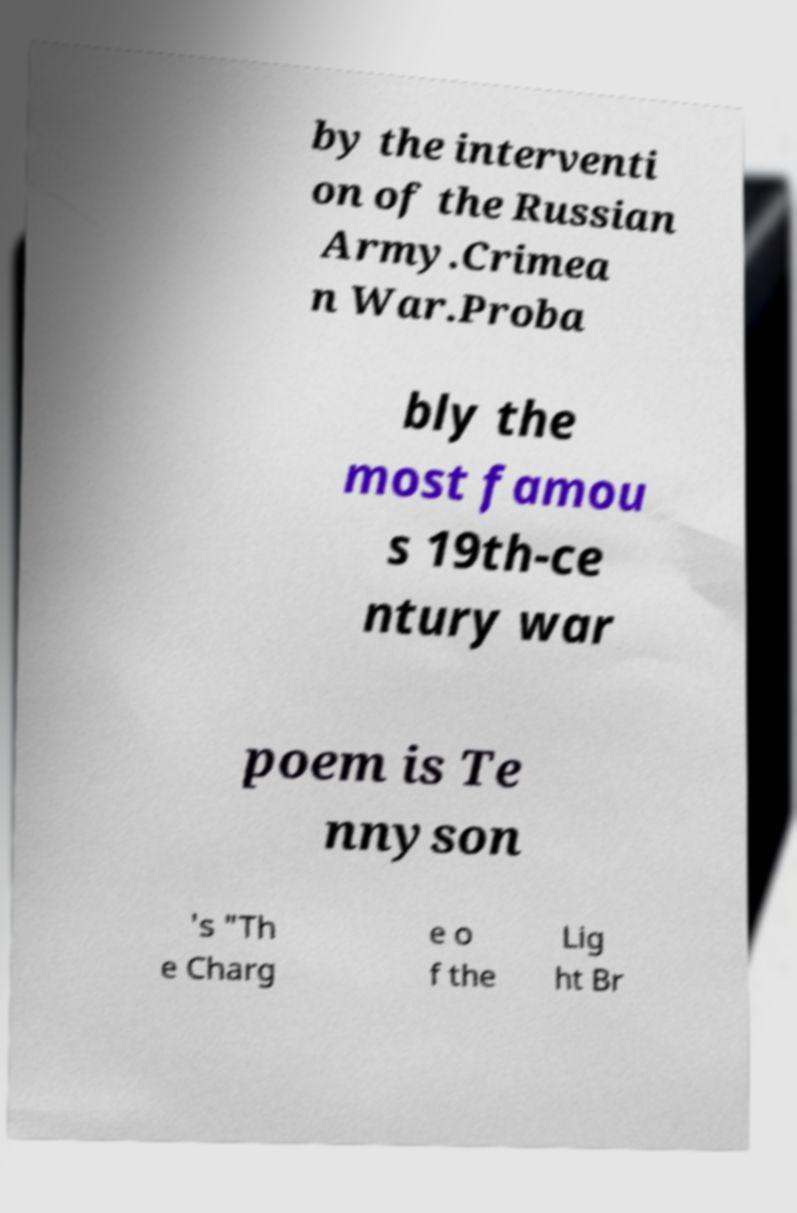Can you read and provide the text displayed in the image?This photo seems to have some interesting text. Can you extract and type it out for me? by the interventi on of the Russian Army.Crimea n War.Proba bly the most famou s 19th-ce ntury war poem is Te nnyson 's "Th e Charg e o f the Lig ht Br 